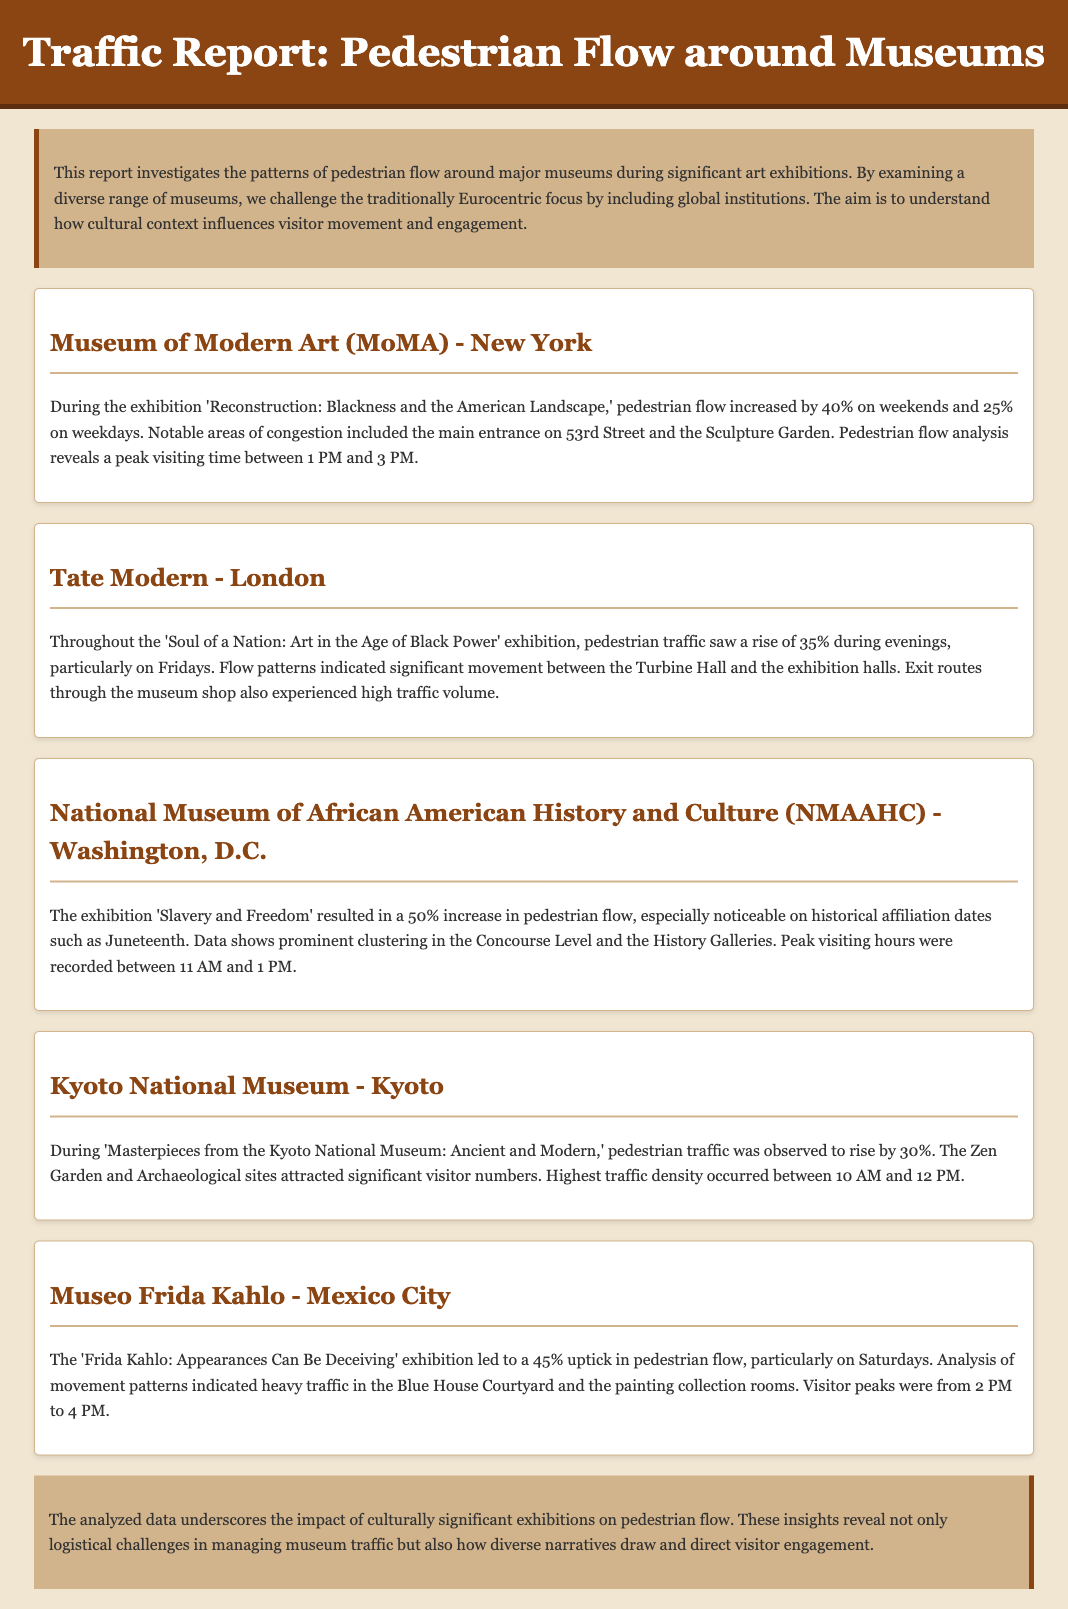What museum had a 40% increase in pedestrian flow? The Museum of Modern Art (MoMA) in New York had a 40% increase in pedestrian flow during the exhibition.
Answer: Museum of Modern Art (MoMA) What was the peak visiting time at the Tate Modern? The peak visiting time at the Tate Modern was during the evenings, particularly on Fridays, as noted in the document.
Answer: Evenings, particularly on Fridays What percentage increase in pedestrian flow did the NMAAHC experience? The National Museum of African American History and Culture experienced a 50% increase in pedestrian flow during the exhibition.
Answer: 50% Which museum had heavy traffic in the Blue House Courtyard? The Museo Frida Kahlo experienced heavy traffic in the Blue House Courtyard during its exhibition.
Answer: Museo Frida Kahlo What was the significant date related to increased traffic at the NMAAHC? The significant date related to increased traffic at the National Museum of African American History and Culture was Juneteenth.
Answer: Juneteenth How much did pedestrian traffic increase at the Kyoto National Museum? Pedestrian traffic at the Kyoto National Museum increased by 30% during its exhibition.
Answer: 30% What is the main focus of this traffic report? The main focus of the report is to investigate pedestrian flow patterns around major museums during significant art exhibitions and challenge Eurocentric narratives.
Answer: Investigating pedestrian flow patterns Which area was notably congested at the MoMA? The main entrance on 53rd Street was notably congested at the Museum of Modern Art.
Answer: Main entrance on 53rd Street 